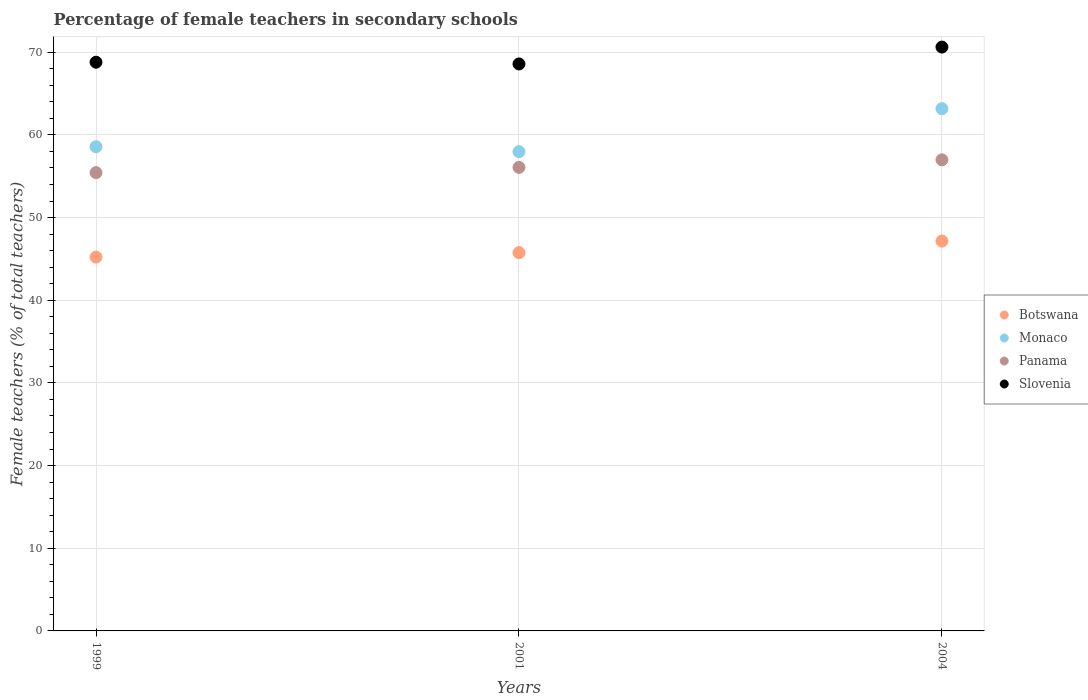How many different coloured dotlines are there?
Provide a succinct answer. 4. What is the percentage of female teachers in Panama in 2001?
Offer a very short reply. 56.07. Across all years, what is the maximum percentage of female teachers in Botswana?
Offer a terse response. 47.16. Across all years, what is the minimum percentage of female teachers in Slovenia?
Offer a very short reply. 68.58. In which year was the percentage of female teachers in Panama maximum?
Your answer should be compact. 2004. In which year was the percentage of female teachers in Botswana minimum?
Offer a very short reply. 1999. What is the total percentage of female teachers in Panama in the graph?
Ensure brevity in your answer.  168.49. What is the difference between the percentage of female teachers in Botswana in 1999 and that in 2004?
Provide a succinct answer. -1.94. What is the difference between the percentage of female teachers in Monaco in 2004 and the percentage of female teachers in Slovenia in 2001?
Provide a succinct answer. -5.41. What is the average percentage of female teachers in Monaco per year?
Provide a succinct answer. 59.91. In the year 1999, what is the difference between the percentage of female teachers in Botswana and percentage of female teachers in Slovenia?
Keep it short and to the point. -23.58. What is the ratio of the percentage of female teachers in Slovenia in 1999 to that in 2001?
Ensure brevity in your answer.  1. Is the percentage of female teachers in Panama in 1999 less than that in 2004?
Ensure brevity in your answer.  Yes. Is the difference between the percentage of female teachers in Botswana in 1999 and 2004 greater than the difference between the percentage of female teachers in Slovenia in 1999 and 2004?
Offer a terse response. No. What is the difference between the highest and the second highest percentage of female teachers in Panama?
Give a very brief answer. 0.92. What is the difference between the highest and the lowest percentage of female teachers in Monaco?
Provide a succinct answer. 5.21. Does the percentage of female teachers in Panama monotonically increase over the years?
Provide a succinct answer. Yes. Is the percentage of female teachers in Botswana strictly less than the percentage of female teachers in Slovenia over the years?
Provide a short and direct response. Yes. How many dotlines are there?
Make the answer very short. 4. Does the graph contain grids?
Provide a succinct answer. Yes. How are the legend labels stacked?
Your answer should be compact. Vertical. What is the title of the graph?
Ensure brevity in your answer.  Percentage of female teachers in secondary schools. What is the label or title of the Y-axis?
Provide a succinct answer. Female teachers (% of total teachers). What is the Female teachers (% of total teachers) of Botswana in 1999?
Offer a terse response. 45.22. What is the Female teachers (% of total teachers) in Monaco in 1999?
Keep it short and to the point. 58.57. What is the Female teachers (% of total teachers) in Panama in 1999?
Ensure brevity in your answer.  55.44. What is the Female teachers (% of total teachers) in Slovenia in 1999?
Your answer should be compact. 68.8. What is the Female teachers (% of total teachers) of Botswana in 2001?
Your answer should be compact. 45.76. What is the Female teachers (% of total teachers) of Monaco in 2001?
Offer a very short reply. 57.97. What is the Female teachers (% of total teachers) in Panama in 2001?
Offer a very short reply. 56.07. What is the Female teachers (% of total teachers) of Slovenia in 2001?
Ensure brevity in your answer.  68.58. What is the Female teachers (% of total teachers) of Botswana in 2004?
Provide a short and direct response. 47.16. What is the Female teachers (% of total teachers) of Monaco in 2004?
Offer a very short reply. 63.18. What is the Female teachers (% of total teachers) in Panama in 2004?
Keep it short and to the point. 56.99. What is the Female teachers (% of total teachers) in Slovenia in 2004?
Your answer should be compact. 70.62. Across all years, what is the maximum Female teachers (% of total teachers) in Botswana?
Provide a succinct answer. 47.16. Across all years, what is the maximum Female teachers (% of total teachers) in Monaco?
Keep it short and to the point. 63.18. Across all years, what is the maximum Female teachers (% of total teachers) of Panama?
Ensure brevity in your answer.  56.99. Across all years, what is the maximum Female teachers (% of total teachers) of Slovenia?
Your response must be concise. 70.62. Across all years, what is the minimum Female teachers (% of total teachers) in Botswana?
Give a very brief answer. 45.22. Across all years, what is the minimum Female teachers (% of total teachers) in Monaco?
Provide a short and direct response. 57.97. Across all years, what is the minimum Female teachers (% of total teachers) of Panama?
Offer a terse response. 55.44. Across all years, what is the minimum Female teachers (% of total teachers) of Slovenia?
Your answer should be very brief. 68.58. What is the total Female teachers (% of total teachers) in Botswana in the graph?
Offer a terse response. 138.14. What is the total Female teachers (% of total teachers) of Monaco in the graph?
Your answer should be compact. 179.72. What is the total Female teachers (% of total teachers) of Panama in the graph?
Give a very brief answer. 168.5. What is the total Female teachers (% of total teachers) of Slovenia in the graph?
Keep it short and to the point. 208.01. What is the difference between the Female teachers (% of total teachers) in Botswana in 1999 and that in 2001?
Offer a very short reply. -0.54. What is the difference between the Female teachers (% of total teachers) in Monaco in 1999 and that in 2001?
Your response must be concise. 0.6. What is the difference between the Female teachers (% of total teachers) in Panama in 1999 and that in 2001?
Offer a terse response. -0.63. What is the difference between the Female teachers (% of total teachers) in Slovenia in 1999 and that in 2001?
Provide a short and direct response. 0.21. What is the difference between the Female teachers (% of total teachers) of Botswana in 1999 and that in 2004?
Make the answer very short. -1.94. What is the difference between the Female teachers (% of total teachers) in Monaco in 1999 and that in 2004?
Your response must be concise. -4.61. What is the difference between the Female teachers (% of total teachers) in Panama in 1999 and that in 2004?
Provide a succinct answer. -1.55. What is the difference between the Female teachers (% of total teachers) of Slovenia in 1999 and that in 2004?
Offer a very short reply. -1.83. What is the difference between the Female teachers (% of total teachers) of Botswana in 2001 and that in 2004?
Your answer should be compact. -1.4. What is the difference between the Female teachers (% of total teachers) of Monaco in 2001 and that in 2004?
Your answer should be compact. -5.21. What is the difference between the Female teachers (% of total teachers) of Panama in 2001 and that in 2004?
Provide a succinct answer. -0.92. What is the difference between the Female teachers (% of total teachers) of Slovenia in 2001 and that in 2004?
Offer a terse response. -2.04. What is the difference between the Female teachers (% of total teachers) in Botswana in 1999 and the Female teachers (% of total teachers) in Monaco in 2001?
Keep it short and to the point. -12.75. What is the difference between the Female teachers (% of total teachers) in Botswana in 1999 and the Female teachers (% of total teachers) in Panama in 2001?
Offer a very short reply. -10.85. What is the difference between the Female teachers (% of total teachers) in Botswana in 1999 and the Female teachers (% of total teachers) in Slovenia in 2001?
Offer a very short reply. -23.36. What is the difference between the Female teachers (% of total teachers) of Monaco in 1999 and the Female teachers (% of total teachers) of Panama in 2001?
Offer a very short reply. 2.5. What is the difference between the Female teachers (% of total teachers) in Monaco in 1999 and the Female teachers (% of total teachers) in Slovenia in 2001?
Provide a short and direct response. -10.01. What is the difference between the Female teachers (% of total teachers) of Panama in 1999 and the Female teachers (% of total teachers) of Slovenia in 2001?
Make the answer very short. -13.15. What is the difference between the Female teachers (% of total teachers) of Botswana in 1999 and the Female teachers (% of total teachers) of Monaco in 2004?
Give a very brief answer. -17.96. What is the difference between the Female teachers (% of total teachers) in Botswana in 1999 and the Female teachers (% of total teachers) in Panama in 2004?
Provide a succinct answer. -11.77. What is the difference between the Female teachers (% of total teachers) of Botswana in 1999 and the Female teachers (% of total teachers) of Slovenia in 2004?
Ensure brevity in your answer.  -25.4. What is the difference between the Female teachers (% of total teachers) of Monaco in 1999 and the Female teachers (% of total teachers) of Panama in 2004?
Make the answer very short. 1.58. What is the difference between the Female teachers (% of total teachers) of Monaco in 1999 and the Female teachers (% of total teachers) of Slovenia in 2004?
Give a very brief answer. -12.05. What is the difference between the Female teachers (% of total teachers) of Panama in 1999 and the Female teachers (% of total teachers) of Slovenia in 2004?
Keep it short and to the point. -15.19. What is the difference between the Female teachers (% of total teachers) of Botswana in 2001 and the Female teachers (% of total teachers) of Monaco in 2004?
Your answer should be very brief. -17.42. What is the difference between the Female teachers (% of total teachers) in Botswana in 2001 and the Female teachers (% of total teachers) in Panama in 2004?
Keep it short and to the point. -11.23. What is the difference between the Female teachers (% of total teachers) of Botswana in 2001 and the Female teachers (% of total teachers) of Slovenia in 2004?
Ensure brevity in your answer.  -24.87. What is the difference between the Female teachers (% of total teachers) of Monaco in 2001 and the Female teachers (% of total teachers) of Panama in 2004?
Offer a very short reply. 0.98. What is the difference between the Female teachers (% of total teachers) of Monaco in 2001 and the Female teachers (% of total teachers) of Slovenia in 2004?
Offer a very short reply. -12.65. What is the difference between the Female teachers (% of total teachers) in Panama in 2001 and the Female teachers (% of total teachers) in Slovenia in 2004?
Your answer should be compact. -14.55. What is the average Female teachers (% of total teachers) in Botswana per year?
Your answer should be compact. 46.05. What is the average Female teachers (% of total teachers) of Monaco per year?
Your answer should be compact. 59.91. What is the average Female teachers (% of total teachers) of Panama per year?
Your response must be concise. 56.16. What is the average Female teachers (% of total teachers) in Slovenia per year?
Provide a succinct answer. 69.34. In the year 1999, what is the difference between the Female teachers (% of total teachers) in Botswana and Female teachers (% of total teachers) in Monaco?
Provide a succinct answer. -13.35. In the year 1999, what is the difference between the Female teachers (% of total teachers) in Botswana and Female teachers (% of total teachers) in Panama?
Your answer should be compact. -10.22. In the year 1999, what is the difference between the Female teachers (% of total teachers) of Botswana and Female teachers (% of total teachers) of Slovenia?
Offer a very short reply. -23.58. In the year 1999, what is the difference between the Female teachers (% of total teachers) of Monaco and Female teachers (% of total teachers) of Panama?
Give a very brief answer. 3.13. In the year 1999, what is the difference between the Female teachers (% of total teachers) in Monaco and Female teachers (% of total teachers) in Slovenia?
Offer a very short reply. -10.22. In the year 1999, what is the difference between the Female teachers (% of total teachers) in Panama and Female teachers (% of total teachers) in Slovenia?
Your answer should be compact. -13.36. In the year 2001, what is the difference between the Female teachers (% of total teachers) in Botswana and Female teachers (% of total teachers) in Monaco?
Your answer should be compact. -12.21. In the year 2001, what is the difference between the Female teachers (% of total teachers) in Botswana and Female teachers (% of total teachers) in Panama?
Offer a terse response. -10.31. In the year 2001, what is the difference between the Female teachers (% of total teachers) of Botswana and Female teachers (% of total teachers) of Slovenia?
Provide a short and direct response. -22.83. In the year 2001, what is the difference between the Female teachers (% of total teachers) in Monaco and Female teachers (% of total teachers) in Panama?
Your response must be concise. 1.9. In the year 2001, what is the difference between the Female teachers (% of total teachers) of Monaco and Female teachers (% of total teachers) of Slovenia?
Give a very brief answer. -10.61. In the year 2001, what is the difference between the Female teachers (% of total teachers) in Panama and Female teachers (% of total teachers) in Slovenia?
Give a very brief answer. -12.51. In the year 2004, what is the difference between the Female teachers (% of total teachers) in Botswana and Female teachers (% of total teachers) in Monaco?
Give a very brief answer. -16.02. In the year 2004, what is the difference between the Female teachers (% of total teachers) in Botswana and Female teachers (% of total teachers) in Panama?
Provide a short and direct response. -9.83. In the year 2004, what is the difference between the Female teachers (% of total teachers) of Botswana and Female teachers (% of total teachers) of Slovenia?
Provide a short and direct response. -23.47. In the year 2004, what is the difference between the Female teachers (% of total teachers) of Monaco and Female teachers (% of total teachers) of Panama?
Offer a terse response. 6.19. In the year 2004, what is the difference between the Female teachers (% of total teachers) of Monaco and Female teachers (% of total teachers) of Slovenia?
Your answer should be compact. -7.45. In the year 2004, what is the difference between the Female teachers (% of total teachers) in Panama and Female teachers (% of total teachers) in Slovenia?
Your response must be concise. -13.64. What is the ratio of the Female teachers (% of total teachers) of Botswana in 1999 to that in 2001?
Offer a very short reply. 0.99. What is the ratio of the Female teachers (% of total teachers) of Monaco in 1999 to that in 2001?
Your response must be concise. 1.01. What is the ratio of the Female teachers (% of total teachers) in Panama in 1999 to that in 2001?
Provide a short and direct response. 0.99. What is the ratio of the Female teachers (% of total teachers) in Slovenia in 1999 to that in 2001?
Provide a short and direct response. 1. What is the ratio of the Female teachers (% of total teachers) of Botswana in 1999 to that in 2004?
Provide a succinct answer. 0.96. What is the ratio of the Female teachers (% of total teachers) in Monaco in 1999 to that in 2004?
Make the answer very short. 0.93. What is the ratio of the Female teachers (% of total teachers) in Panama in 1999 to that in 2004?
Keep it short and to the point. 0.97. What is the ratio of the Female teachers (% of total teachers) in Slovenia in 1999 to that in 2004?
Offer a very short reply. 0.97. What is the ratio of the Female teachers (% of total teachers) in Botswana in 2001 to that in 2004?
Make the answer very short. 0.97. What is the ratio of the Female teachers (% of total teachers) of Monaco in 2001 to that in 2004?
Offer a very short reply. 0.92. What is the ratio of the Female teachers (% of total teachers) of Panama in 2001 to that in 2004?
Keep it short and to the point. 0.98. What is the ratio of the Female teachers (% of total teachers) of Slovenia in 2001 to that in 2004?
Offer a terse response. 0.97. What is the difference between the highest and the second highest Female teachers (% of total teachers) of Botswana?
Offer a terse response. 1.4. What is the difference between the highest and the second highest Female teachers (% of total teachers) of Monaco?
Provide a short and direct response. 4.61. What is the difference between the highest and the second highest Female teachers (% of total teachers) in Panama?
Offer a very short reply. 0.92. What is the difference between the highest and the second highest Female teachers (% of total teachers) of Slovenia?
Offer a very short reply. 1.83. What is the difference between the highest and the lowest Female teachers (% of total teachers) of Botswana?
Offer a very short reply. 1.94. What is the difference between the highest and the lowest Female teachers (% of total teachers) in Monaco?
Ensure brevity in your answer.  5.21. What is the difference between the highest and the lowest Female teachers (% of total teachers) in Panama?
Give a very brief answer. 1.55. What is the difference between the highest and the lowest Female teachers (% of total teachers) of Slovenia?
Your answer should be compact. 2.04. 